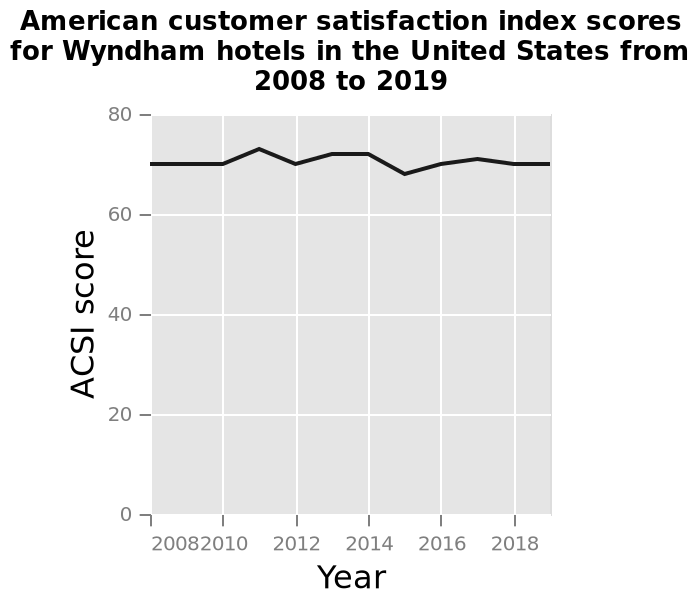<image>
please enumerates aspects of the construction of the chart Here a line diagram is titled American customer satisfaction index scores for Wyndham hotels in the United States from 2008 to 2019. The x-axis shows Year along linear scale of range 2008 to 2018 while the y-axis plots ACSI score using linear scale from 0 to 80. please summary the statistics and relations of the chart The highest customer satisfaction index scores for Wyndham hotels in the US was achieved in 2011. The lowest satisfaction rating were in 2015. When were the lowest satisfaction ratings for Wyndham hotels in the US?  The lowest satisfaction ratings for Wyndham hotels in the US were in 2015. 